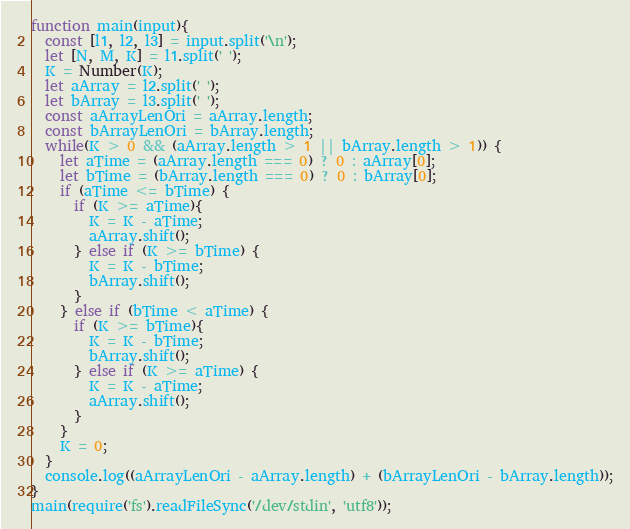<code> <loc_0><loc_0><loc_500><loc_500><_JavaScript_>function main(input){
  const [l1, l2, l3] = input.split('\n');
  let [N, M, K] = l1.split(' ');
  K = Number(K);
  let aArray = l2.split(' ');
  let bArray = l3.split(' ');
  const aArrayLenOri = aArray.length;
  const bArrayLenOri = bArray.length;
  while(K > 0 && (aArray.length > 1 || bArray.length > 1)) {
    let aTime = (aArray.length === 0) ? 0 : aArray[0];
    let bTime = (bArray.length === 0) ? 0 : bArray[0];
    if (aTime <= bTime) {
      if (K >= aTime){
        K = K - aTime;
        aArray.shift();
      } else if (K >= bTime) {
        K = K - bTime;
        bArray.shift();
      }
    } else if (bTime < aTime) {
      if (K >= bTime){
        K = K - bTime;
        bArray.shift();
      } else if (K >= aTime) {
        K = K - aTime;
        aArray.shift();
      }
    }
    K = 0;
  }
  console.log((aArrayLenOri - aArray.length) + (bArrayLenOri - bArray.length));
}
main(require('fs').readFileSync('/dev/stdin', 'utf8'));</code> 